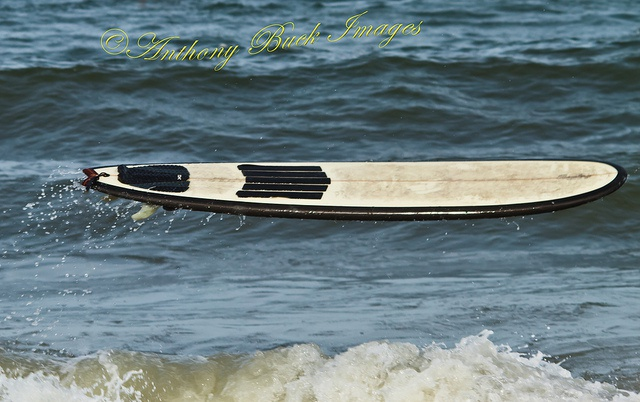Describe the objects in this image and their specific colors. I can see a surfboard in blue, beige, black, and gray tones in this image. 